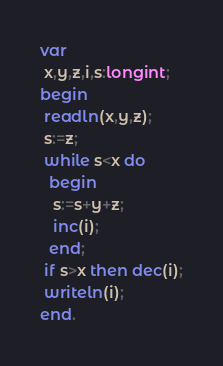Convert code to text. <code><loc_0><loc_0><loc_500><loc_500><_Pascal_>var
 x,y,z,i,s:longint;
begin
 readln(x,y,z);
 s:=z;
 while s<x do
  begin
   s:=s+y+z;
   inc(i);
  end;
 if s>x then dec(i);
 writeln(i);
end.</code> 